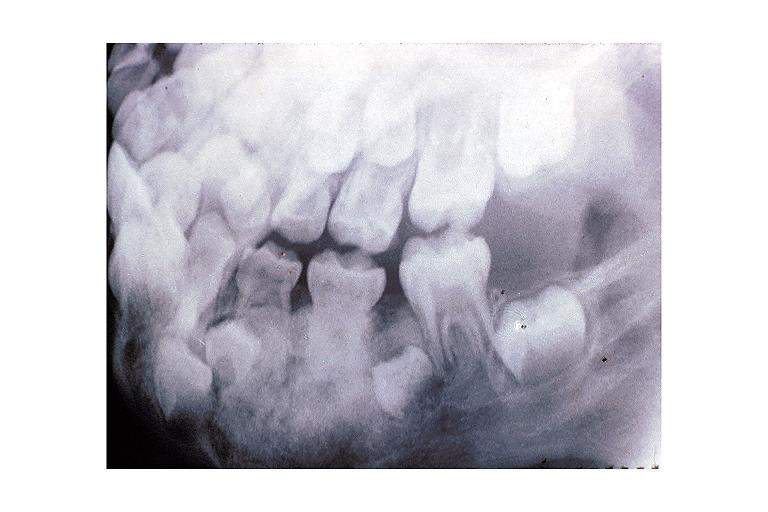does child show osteoblastoma?
Answer the question using a single word or phrase. No 